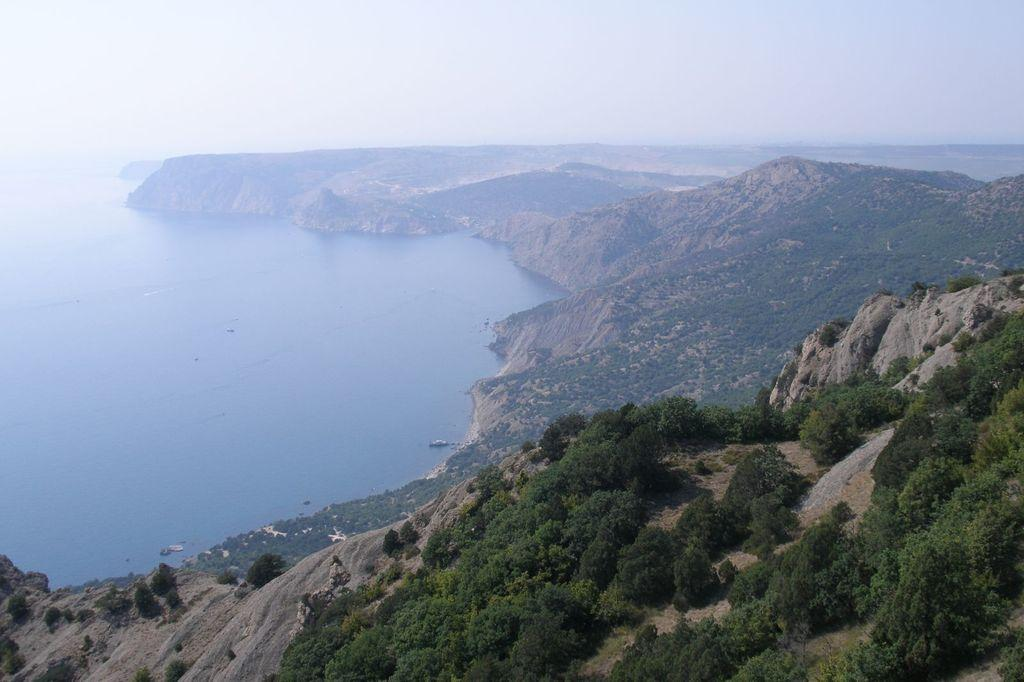What type of natural feature is located on the left side of the image? There is a river on the left side of the image. What other geographical features can be seen in the image? There are hills and trees in the image. What is visible in the background of the image? The sky is visible in the background of the image. Where is the library located in the image? There is no library present in the image. What type of animal can be seen with fangs in the image? There are no animals or fangs present in the image. 